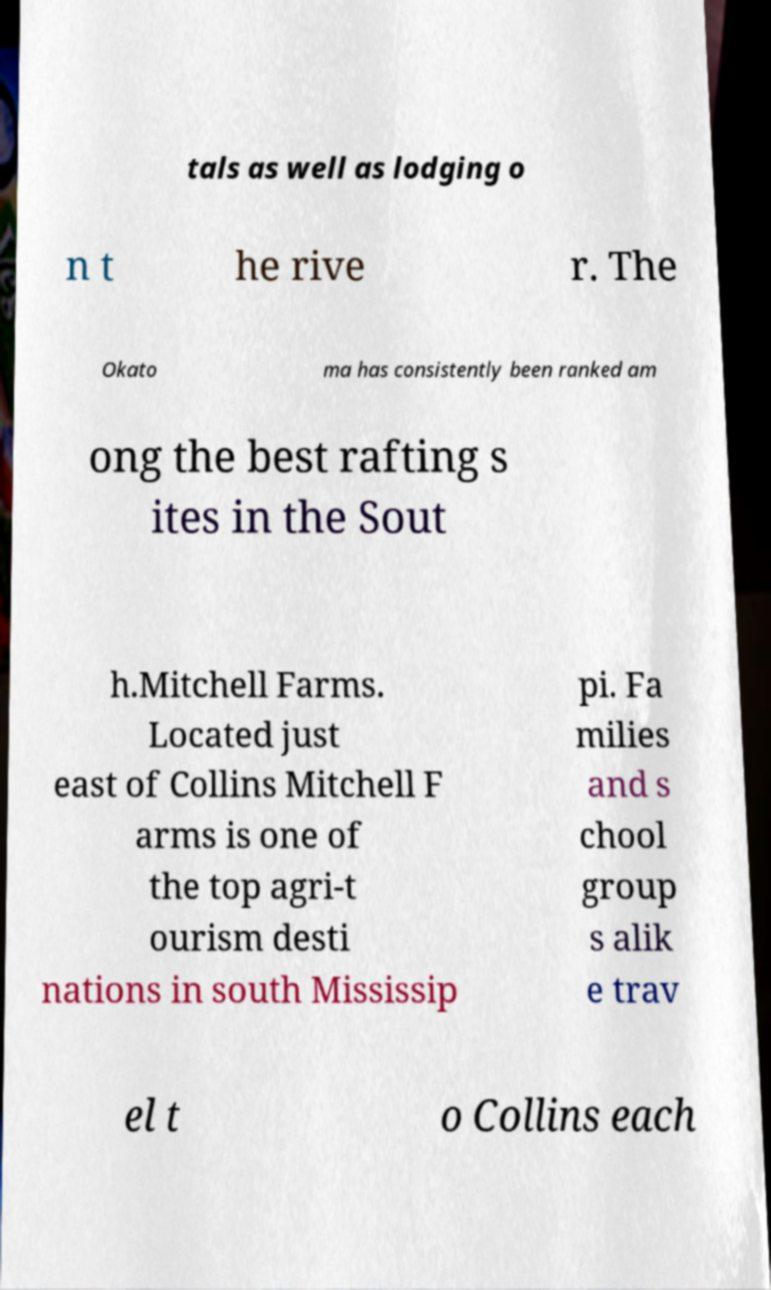For documentation purposes, I need the text within this image transcribed. Could you provide that? tals as well as lodging o n t he rive r. The Okato ma has consistently been ranked am ong the best rafting s ites in the Sout h.Mitchell Farms. Located just east of Collins Mitchell F arms is one of the top agri-t ourism desti nations in south Mississip pi. Fa milies and s chool group s alik e trav el t o Collins each 